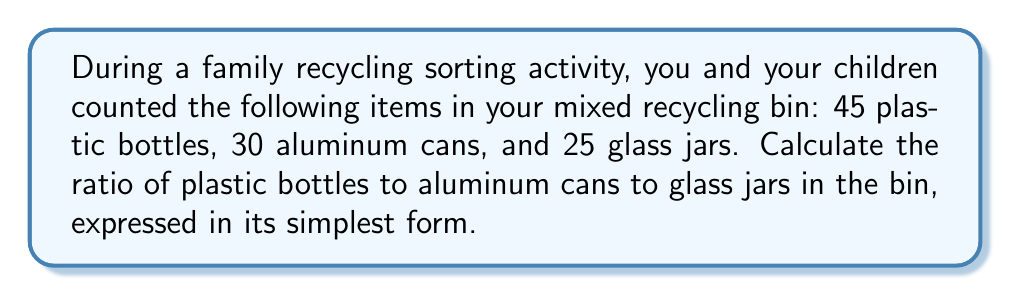Give your solution to this math problem. To solve this problem, we'll follow these steps:

1. List the quantities of each type of recyclable:
   - Plastic bottles: 45
   - Aluminum cans: 30
   - Glass jars: 25

2. Write the initial ratio using these quantities:
   $$45 : 30 : 25$$

3. To simplify the ratio, we need to find the greatest common divisor (GCD) of all three numbers:
   $$GCD(45, 30, 25) = 5$$

4. Divide each number in the ratio by the GCD:
   $$\frac{45}{5} : \frac{30}{5} : \frac{25}{5}$$

5. Simplify:
   $$9 : 6 : 5$$

This simplified ratio cannot be reduced further, as 9, 6, and 5 have no common factors other than 1.
Answer: The simplified ratio of plastic bottles to aluminum cans to glass jars is $9 : 6 : 5$. 